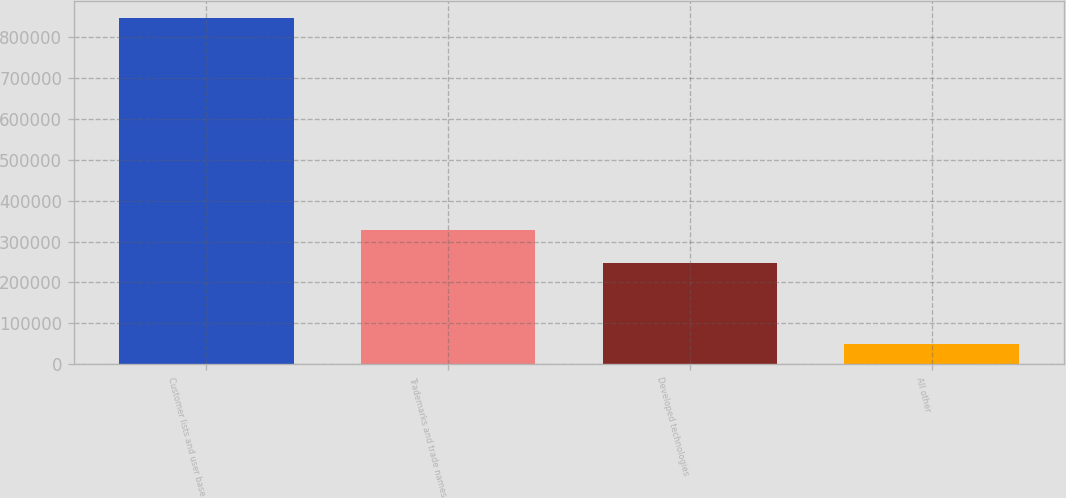Convert chart. <chart><loc_0><loc_0><loc_500><loc_500><bar_chart><fcel>Customer lists and user base<fcel>Trademarks and trade names<fcel>Developed technologies<fcel>All other<nl><fcel>846800<fcel>328343<fcel>248655<fcel>49923<nl></chart> 